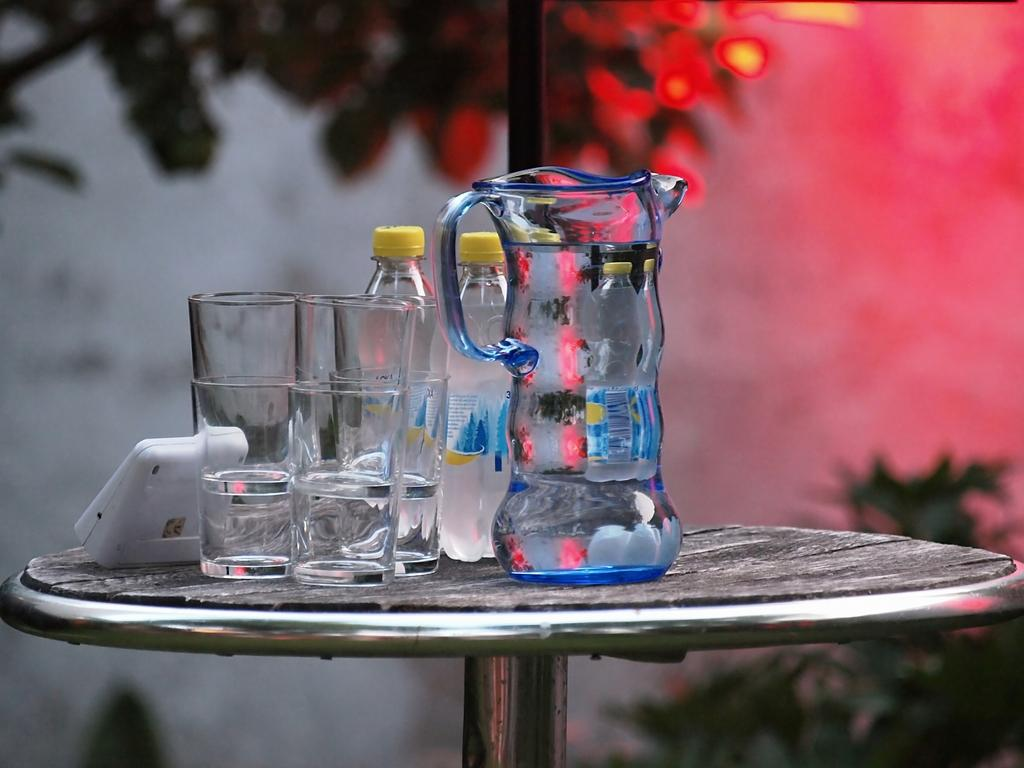What objects are on the table in the image? There are glasses, two bottles, and a jug on the table in the image. Can you describe the plant in the background of the image? Unfortunately, the facts provided do not give any information about the plant in the background. How many bottles are on the table? There are two bottles on the table. What page of the book is the person reading in the image? There is no book or person reading in the image; it only shows objects on a table. What type of shop is depicted in the image? There is no shop depicted in the image; it only shows objects on a table. 